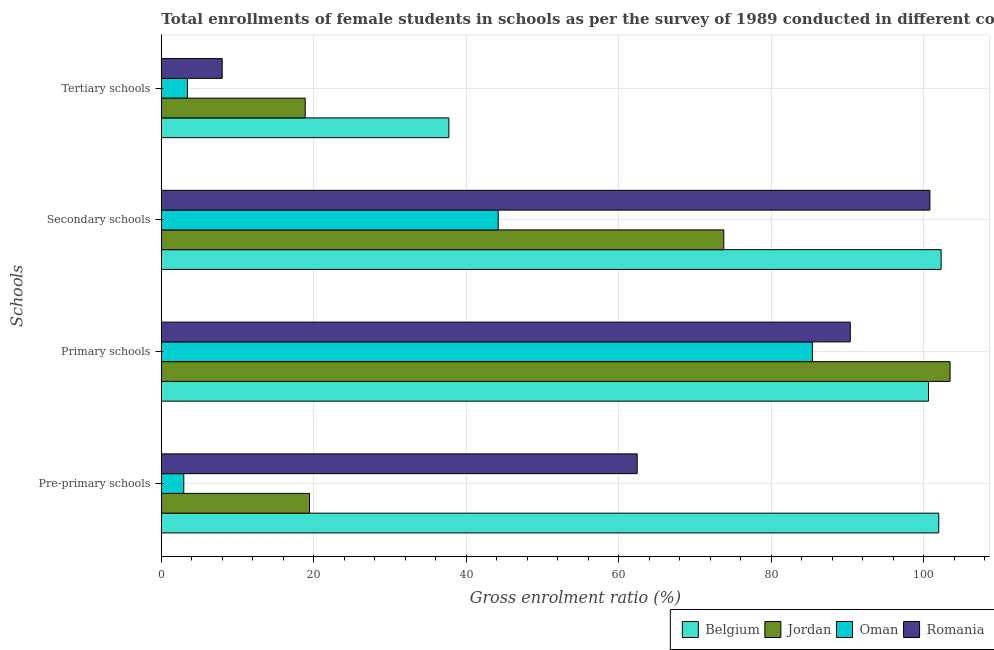How many groups of bars are there?
Make the answer very short. 4. How many bars are there on the 2nd tick from the bottom?
Give a very brief answer. 4. What is the label of the 1st group of bars from the top?
Offer a very short reply. Tertiary schools. What is the gross enrolment ratio(female) in tertiary schools in Jordan?
Offer a terse response. 18.88. Across all countries, what is the maximum gross enrolment ratio(female) in tertiary schools?
Your answer should be very brief. 37.73. Across all countries, what is the minimum gross enrolment ratio(female) in secondary schools?
Ensure brevity in your answer.  44.2. In which country was the gross enrolment ratio(female) in primary schools maximum?
Give a very brief answer. Jordan. In which country was the gross enrolment ratio(female) in secondary schools minimum?
Your answer should be compact. Oman. What is the total gross enrolment ratio(female) in pre-primary schools in the graph?
Your answer should be compact. 186.82. What is the difference between the gross enrolment ratio(female) in primary schools in Romania and that in Belgium?
Offer a very short reply. -10.26. What is the difference between the gross enrolment ratio(female) in tertiary schools in Oman and the gross enrolment ratio(female) in secondary schools in Romania?
Your answer should be very brief. -97.41. What is the average gross enrolment ratio(female) in tertiary schools per country?
Make the answer very short. 17. What is the difference between the gross enrolment ratio(female) in pre-primary schools and gross enrolment ratio(female) in secondary schools in Jordan?
Provide a short and direct response. -54.35. In how many countries, is the gross enrolment ratio(female) in secondary schools greater than 16 %?
Offer a very short reply. 4. What is the ratio of the gross enrolment ratio(female) in tertiary schools in Romania to that in Jordan?
Keep it short and to the point. 0.42. Is the gross enrolment ratio(female) in tertiary schools in Jordan less than that in Belgium?
Keep it short and to the point. Yes. Is the difference between the gross enrolment ratio(female) in primary schools in Belgium and Romania greater than the difference between the gross enrolment ratio(female) in tertiary schools in Belgium and Romania?
Offer a very short reply. No. What is the difference between the highest and the second highest gross enrolment ratio(female) in pre-primary schools?
Offer a very short reply. 39.56. What is the difference between the highest and the lowest gross enrolment ratio(female) in pre-primary schools?
Provide a short and direct response. 99.05. In how many countries, is the gross enrolment ratio(female) in secondary schools greater than the average gross enrolment ratio(female) in secondary schools taken over all countries?
Your response must be concise. 2. Is the sum of the gross enrolment ratio(female) in primary schools in Oman and Romania greater than the maximum gross enrolment ratio(female) in tertiary schools across all countries?
Your response must be concise. Yes. Is it the case that in every country, the sum of the gross enrolment ratio(female) in primary schools and gross enrolment ratio(female) in secondary schools is greater than the sum of gross enrolment ratio(female) in pre-primary schools and gross enrolment ratio(female) in tertiary schools?
Offer a very short reply. Yes. What does the 1st bar from the top in Tertiary schools represents?
Provide a short and direct response. Romania. What does the 3rd bar from the bottom in Primary schools represents?
Your answer should be very brief. Oman. How many bars are there?
Provide a short and direct response. 16. How many countries are there in the graph?
Ensure brevity in your answer.  4. Where does the legend appear in the graph?
Offer a terse response. Bottom right. How many legend labels are there?
Your response must be concise. 4. How are the legend labels stacked?
Make the answer very short. Horizontal. What is the title of the graph?
Offer a terse response. Total enrollments of female students in schools as per the survey of 1989 conducted in different countries. Does "Burundi" appear as one of the legend labels in the graph?
Keep it short and to the point. No. What is the label or title of the X-axis?
Offer a very short reply. Gross enrolment ratio (%). What is the label or title of the Y-axis?
Offer a terse response. Schools. What is the Gross enrolment ratio (%) in Belgium in Pre-primary schools?
Provide a succinct answer. 101.99. What is the Gross enrolment ratio (%) of Jordan in Pre-primary schools?
Offer a terse response. 19.44. What is the Gross enrolment ratio (%) in Oman in Pre-primary schools?
Your answer should be compact. 2.95. What is the Gross enrolment ratio (%) in Romania in Pre-primary schools?
Give a very brief answer. 62.43. What is the Gross enrolment ratio (%) of Belgium in Primary schools?
Offer a very short reply. 100.65. What is the Gross enrolment ratio (%) of Jordan in Primary schools?
Your response must be concise. 103.48. What is the Gross enrolment ratio (%) of Oman in Primary schools?
Provide a short and direct response. 85.43. What is the Gross enrolment ratio (%) in Romania in Primary schools?
Give a very brief answer. 90.39. What is the Gross enrolment ratio (%) of Belgium in Secondary schools?
Give a very brief answer. 102.31. What is the Gross enrolment ratio (%) in Jordan in Secondary schools?
Provide a succinct answer. 73.8. What is the Gross enrolment ratio (%) in Oman in Secondary schools?
Give a very brief answer. 44.2. What is the Gross enrolment ratio (%) in Romania in Secondary schools?
Your response must be concise. 100.83. What is the Gross enrolment ratio (%) of Belgium in Tertiary schools?
Your answer should be very brief. 37.73. What is the Gross enrolment ratio (%) in Jordan in Tertiary schools?
Keep it short and to the point. 18.88. What is the Gross enrolment ratio (%) of Oman in Tertiary schools?
Ensure brevity in your answer.  3.43. What is the Gross enrolment ratio (%) in Romania in Tertiary schools?
Provide a succinct answer. 7.99. Across all Schools, what is the maximum Gross enrolment ratio (%) of Belgium?
Provide a short and direct response. 102.31. Across all Schools, what is the maximum Gross enrolment ratio (%) in Jordan?
Provide a succinct answer. 103.48. Across all Schools, what is the maximum Gross enrolment ratio (%) in Oman?
Provide a short and direct response. 85.43. Across all Schools, what is the maximum Gross enrolment ratio (%) in Romania?
Make the answer very short. 100.83. Across all Schools, what is the minimum Gross enrolment ratio (%) in Belgium?
Ensure brevity in your answer.  37.73. Across all Schools, what is the minimum Gross enrolment ratio (%) in Jordan?
Your response must be concise. 18.88. Across all Schools, what is the minimum Gross enrolment ratio (%) of Oman?
Ensure brevity in your answer.  2.95. Across all Schools, what is the minimum Gross enrolment ratio (%) in Romania?
Provide a short and direct response. 7.99. What is the total Gross enrolment ratio (%) in Belgium in the graph?
Your response must be concise. 342.68. What is the total Gross enrolment ratio (%) in Jordan in the graph?
Provide a short and direct response. 215.59. What is the total Gross enrolment ratio (%) of Oman in the graph?
Provide a succinct answer. 136. What is the total Gross enrolment ratio (%) of Romania in the graph?
Keep it short and to the point. 261.64. What is the difference between the Gross enrolment ratio (%) of Belgium in Pre-primary schools and that in Primary schools?
Your answer should be very brief. 1.35. What is the difference between the Gross enrolment ratio (%) in Jordan in Pre-primary schools and that in Primary schools?
Provide a succinct answer. -84.03. What is the difference between the Gross enrolment ratio (%) in Oman in Pre-primary schools and that in Primary schools?
Ensure brevity in your answer.  -82.48. What is the difference between the Gross enrolment ratio (%) in Romania in Pre-primary schools and that in Primary schools?
Your answer should be compact. -27.96. What is the difference between the Gross enrolment ratio (%) in Belgium in Pre-primary schools and that in Secondary schools?
Your answer should be compact. -0.31. What is the difference between the Gross enrolment ratio (%) of Jordan in Pre-primary schools and that in Secondary schools?
Ensure brevity in your answer.  -54.35. What is the difference between the Gross enrolment ratio (%) in Oman in Pre-primary schools and that in Secondary schools?
Your answer should be compact. -41.25. What is the difference between the Gross enrolment ratio (%) of Romania in Pre-primary schools and that in Secondary schools?
Provide a short and direct response. -38.4. What is the difference between the Gross enrolment ratio (%) of Belgium in Pre-primary schools and that in Tertiary schools?
Offer a terse response. 64.27. What is the difference between the Gross enrolment ratio (%) in Jordan in Pre-primary schools and that in Tertiary schools?
Offer a terse response. 0.57. What is the difference between the Gross enrolment ratio (%) of Oman in Pre-primary schools and that in Tertiary schools?
Your answer should be compact. -0.48. What is the difference between the Gross enrolment ratio (%) of Romania in Pre-primary schools and that in Tertiary schools?
Offer a terse response. 54.45. What is the difference between the Gross enrolment ratio (%) of Belgium in Primary schools and that in Secondary schools?
Keep it short and to the point. -1.66. What is the difference between the Gross enrolment ratio (%) of Jordan in Primary schools and that in Secondary schools?
Offer a terse response. 29.68. What is the difference between the Gross enrolment ratio (%) in Oman in Primary schools and that in Secondary schools?
Provide a succinct answer. 41.23. What is the difference between the Gross enrolment ratio (%) of Romania in Primary schools and that in Secondary schools?
Provide a succinct answer. -10.44. What is the difference between the Gross enrolment ratio (%) of Belgium in Primary schools and that in Tertiary schools?
Keep it short and to the point. 62.92. What is the difference between the Gross enrolment ratio (%) of Jordan in Primary schools and that in Tertiary schools?
Keep it short and to the point. 84.6. What is the difference between the Gross enrolment ratio (%) in Oman in Primary schools and that in Tertiary schools?
Make the answer very short. 82. What is the difference between the Gross enrolment ratio (%) of Romania in Primary schools and that in Tertiary schools?
Provide a succinct answer. 82.4. What is the difference between the Gross enrolment ratio (%) in Belgium in Secondary schools and that in Tertiary schools?
Offer a terse response. 64.58. What is the difference between the Gross enrolment ratio (%) of Jordan in Secondary schools and that in Tertiary schools?
Your response must be concise. 54.92. What is the difference between the Gross enrolment ratio (%) in Oman in Secondary schools and that in Tertiary schools?
Make the answer very short. 40.77. What is the difference between the Gross enrolment ratio (%) in Romania in Secondary schools and that in Tertiary schools?
Provide a short and direct response. 92.85. What is the difference between the Gross enrolment ratio (%) in Belgium in Pre-primary schools and the Gross enrolment ratio (%) in Jordan in Primary schools?
Make the answer very short. -1.48. What is the difference between the Gross enrolment ratio (%) of Belgium in Pre-primary schools and the Gross enrolment ratio (%) of Oman in Primary schools?
Your response must be concise. 16.57. What is the difference between the Gross enrolment ratio (%) of Belgium in Pre-primary schools and the Gross enrolment ratio (%) of Romania in Primary schools?
Your answer should be compact. 11.61. What is the difference between the Gross enrolment ratio (%) in Jordan in Pre-primary schools and the Gross enrolment ratio (%) in Oman in Primary schools?
Offer a very short reply. -65.98. What is the difference between the Gross enrolment ratio (%) in Jordan in Pre-primary schools and the Gross enrolment ratio (%) in Romania in Primary schools?
Offer a very short reply. -70.95. What is the difference between the Gross enrolment ratio (%) in Oman in Pre-primary schools and the Gross enrolment ratio (%) in Romania in Primary schools?
Ensure brevity in your answer.  -87.44. What is the difference between the Gross enrolment ratio (%) of Belgium in Pre-primary schools and the Gross enrolment ratio (%) of Jordan in Secondary schools?
Ensure brevity in your answer.  28.2. What is the difference between the Gross enrolment ratio (%) of Belgium in Pre-primary schools and the Gross enrolment ratio (%) of Oman in Secondary schools?
Your response must be concise. 57.8. What is the difference between the Gross enrolment ratio (%) of Belgium in Pre-primary schools and the Gross enrolment ratio (%) of Romania in Secondary schools?
Your answer should be very brief. 1.16. What is the difference between the Gross enrolment ratio (%) in Jordan in Pre-primary schools and the Gross enrolment ratio (%) in Oman in Secondary schools?
Your answer should be very brief. -24.75. What is the difference between the Gross enrolment ratio (%) in Jordan in Pre-primary schools and the Gross enrolment ratio (%) in Romania in Secondary schools?
Provide a short and direct response. -81.39. What is the difference between the Gross enrolment ratio (%) in Oman in Pre-primary schools and the Gross enrolment ratio (%) in Romania in Secondary schools?
Your response must be concise. -97.88. What is the difference between the Gross enrolment ratio (%) in Belgium in Pre-primary schools and the Gross enrolment ratio (%) in Jordan in Tertiary schools?
Your response must be concise. 83.12. What is the difference between the Gross enrolment ratio (%) of Belgium in Pre-primary schools and the Gross enrolment ratio (%) of Oman in Tertiary schools?
Your answer should be compact. 98.57. What is the difference between the Gross enrolment ratio (%) in Belgium in Pre-primary schools and the Gross enrolment ratio (%) in Romania in Tertiary schools?
Provide a short and direct response. 94.01. What is the difference between the Gross enrolment ratio (%) of Jordan in Pre-primary schools and the Gross enrolment ratio (%) of Oman in Tertiary schools?
Keep it short and to the point. 16.02. What is the difference between the Gross enrolment ratio (%) of Jordan in Pre-primary schools and the Gross enrolment ratio (%) of Romania in Tertiary schools?
Offer a terse response. 11.46. What is the difference between the Gross enrolment ratio (%) in Oman in Pre-primary schools and the Gross enrolment ratio (%) in Romania in Tertiary schools?
Your answer should be compact. -5.04. What is the difference between the Gross enrolment ratio (%) in Belgium in Primary schools and the Gross enrolment ratio (%) in Jordan in Secondary schools?
Ensure brevity in your answer.  26.85. What is the difference between the Gross enrolment ratio (%) of Belgium in Primary schools and the Gross enrolment ratio (%) of Oman in Secondary schools?
Offer a terse response. 56.45. What is the difference between the Gross enrolment ratio (%) in Belgium in Primary schools and the Gross enrolment ratio (%) in Romania in Secondary schools?
Offer a very short reply. -0.19. What is the difference between the Gross enrolment ratio (%) of Jordan in Primary schools and the Gross enrolment ratio (%) of Oman in Secondary schools?
Provide a short and direct response. 59.28. What is the difference between the Gross enrolment ratio (%) in Jordan in Primary schools and the Gross enrolment ratio (%) in Romania in Secondary schools?
Your answer should be compact. 2.65. What is the difference between the Gross enrolment ratio (%) in Oman in Primary schools and the Gross enrolment ratio (%) in Romania in Secondary schools?
Keep it short and to the point. -15.41. What is the difference between the Gross enrolment ratio (%) of Belgium in Primary schools and the Gross enrolment ratio (%) of Jordan in Tertiary schools?
Offer a terse response. 81.77. What is the difference between the Gross enrolment ratio (%) of Belgium in Primary schools and the Gross enrolment ratio (%) of Oman in Tertiary schools?
Your answer should be compact. 97.22. What is the difference between the Gross enrolment ratio (%) in Belgium in Primary schools and the Gross enrolment ratio (%) in Romania in Tertiary schools?
Make the answer very short. 92.66. What is the difference between the Gross enrolment ratio (%) of Jordan in Primary schools and the Gross enrolment ratio (%) of Oman in Tertiary schools?
Ensure brevity in your answer.  100.05. What is the difference between the Gross enrolment ratio (%) of Jordan in Primary schools and the Gross enrolment ratio (%) of Romania in Tertiary schools?
Offer a very short reply. 95.49. What is the difference between the Gross enrolment ratio (%) of Oman in Primary schools and the Gross enrolment ratio (%) of Romania in Tertiary schools?
Your answer should be very brief. 77.44. What is the difference between the Gross enrolment ratio (%) of Belgium in Secondary schools and the Gross enrolment ratio (%) of Jordan in Tertiary schools?
Your answer should be compact. 83.43. What is the difference between the Gross enrolment ratio (%) in Belgium in Secondary schools and the Gross enrolment ratio (%) in Oman in Tertiary schools?
Provide a short and direct response. 98.88. What is the difference between the Gross enrolment ratio (%) in Belgium in Secondary schools and the Gross enrolment ratio (%) in Romania in Tertiary schools?
Your answer should be compact. 94.32. What is the difference between the Gross enrolment ratio (%) of Jordan in Secondary schools and the Gross enrolment ratio (%) of Oman in Tertiary schools?
Provide a short and direct response. 70.37. What is the difference between the Gross enrolment ratio (%) of Jordan in Secondary schools and the Gross enrolment ratio (%) of Romania in Tertiary schools?
Give a very brief answer. 65.81. What is the difference between the Gross enrolment ratio (%) of Oman in Secondary schools and the Gross enrolment ratio (%) of Romania in Tertiary schools?
Provide a succinct answer. 36.21. What is the average Gross enrolment ratio (%) of Belgium per Schools?
Ensure brevity in your answer.  85.67. What is the average Gross enrolment ratio (%) in Jordan per Schools?
Make the answer very short. 53.9. What is the average Gross enrolment ratio (%) in Oman per Schools?
Give a very brief answer. 34. What is the average Gross enrolment ratio (%) in Romania per Schools?
Your response must be concise. 65.41. What is the difference between the Gross enrolment ratio (%) of Belgium and Gross enrolment ratio (%) of Jordan in Pre-primary schools?
Your answer should be very brief. 82.55. What is the difference between the Gross enrolment ratio (%) of Belgium and Gross enrolment ratio (%) of Oman in Pre-primary schools?
Provide a succinct answer. 99.05. What is the difference between the Gross enrolment ratio (%) in Belgium and Gross enrolment ratio (%) in Romania in Pre-primary schools?
Your response must be concise. 39.56. What is the difference between the Gross enrolment ratio (%) of Jordan and Gross enrolment ratio (%) of Oman in Pre-primary schools?
Your answer should be very brief. 16.5. What is the difference between the Gross enrolment ratio (%) in Jordan and Gross enrolment ratio (%) in Romania in Pre-primary schools?
Provide a short and direct response. -42.99. What is the difference between the Gross enrolment ratio (%) of Oman and Gross enrolment ratio (%) of Romania in Pre-primary schools?
Your response must be concise. -59.49. What is the difference between the Gross enrolment ratio (%) in Belgium and Gross enrolment ratio (%) in Jordan in Primary schools?
Make the answer very short. -2.83. What is the difference between the Gross enrolment ratio (%) in Belgium and Gross enrolment ratio (%) in Oman in Primary schools?
Offer a terse response. 15.22. What is the difference between the Gross enrolment ratio (%) in Belgium and Gross enrolment ratio (%) in Romania in Primary schools?
Keep it short and to the point. 10.26. What is the difference between the Gross enrolment ratio (%) in Jordan and Gross enrolment ratio (%) in Oman in Primary schools?
Your answer should be very brief. 18.05. What is the difference between the Gross enrolment ratio (%) in Jordan and Gross enrolment ratio (%) in Romania in Primary schools?
Your response must be concise. 13.09. What is the difference between the Gross enrolment ratio (%) of Oman and Gross enrolment ratio (%) of Romania in Primary schools?
Provide a succinct answer. -4.96. What is the difference between the Gross enrolment ratio (%) in Belgium and Gross enrolment ratio (%) in Jordan in Secondary schools?
Provide a succinct answer. 28.51. What is the difference between the Gross enrolment ratio (%) in Belgium and Gross enrolment ratio (%) in Oman in Secondary schools?
Provide a succinct answer. 58.11. What is the difference between the Gross enrolment ratio (%) of Belgium and Gross enrolment ratio (%) of Romania in Secondary schools?
Give a very brief answer. 1.47. What is the difference between the Gross enrolment ratio (%) in Jordan and Gross enrolment ratio (%) in Oman in Secondary schools?
Provide a succinct answer. 29.6. What is the difference between the Gross enrolment ratio (%) in Jordan and Gross enrolment ratio (%) in Romania in Secondary schools?
Provide a succinct answer. -27.04. What is the difference between the Gross enrolment ratio (%) in Oman and Gross enrolment ratio (%) in Romania in Secondary schools?
Ensure brevity in your answer.  -56.64. What is the difference between the Gross enrolment ratio (%) of Belgium and Gross enrolment ratio (%) of Jordan in Tertiary schools?
Make the answer very short. 18.85. What is the difference between the Gross enrolment ratio (%) of Belgium and Gross enrolment ratio (%) of Oman in Tertiary schools?
Your answer should be compact. 34.3. What is the difference between the Gross enrolment ratio (%) of Belgium and Gross enrolment ratio (%) of Romania in Tertiary schools?
Offer a terse response. 29.74. What is the difference between the Gross enrolment ratio (%) of Jordan and Gross enrolment ratio (%) of Oman in Tertiary schools?
Your response must be concise. 15.45. What is the difference between the Gross enrolment ratio (%) in Jordan and Gross enrolment ratio (%) in Romania in Tertiary schools?
Ensure brevity in your answer.  10.89. What is the difference between the Gross enrolment ratio (%) of Oman and Gross enrolment ratio (%) of Romania in Tertiary schools?
Give a very brief answer. -4.56. What is the ratio of the Gross enrolment ratio (%) of Belgium in Pre-primary schools to that in Primary schools?
Your answer should be very brief. 1.01. What is the ratio of the Gross enrolment ratio (%) in Jordan in Pre-primary schools to that in Primary schools?
Ensure brevity in your answer.  0.19. What is the ratio of the Gross enrolment ratio (%) in Oman in Pre-primary schools to that in Primary schools?
Offer a very short reply. 0.03. What is the ratio of the Gross enrolment ratio (%) of Romania in Pre-primary schools to that in Primary schools?
Your answer should be very brief. 0.69. What is the ratio of the Gross enrolment ratio (%) in Jordan in Pre-primary schools to that in Secondary schools?
Make the answer very short. 0.26. What is the ratio of the Gross enrolment ratio (%) of Oman in Pre-primary schools to that in Secondary schools?
Ensure brevity in your answer.  0.07. What is the ratio of the Gross enrolment ratio (%) of Romania in Pre-primary schools to that in Secondary schools?
Ensure brevity in your answer.  0.62. What is the ratio of the Gross enrolment ratio (%) in Belgium in Pre-primary schools to that in Tertiary schools?
Keep it short and to the point. 2.7. What is the ratio of the Gross enrolment ratio (%) in Jordan in Pre-primary schools to that in Tertiary schools?
Ensure brevity in your answer.  1.03. What is the ratio of the Gross enrolment ratio (%) in Oman in Pre-primary schools to that in Tertiary schools?
Your response must be concise. 0.86. What is the ratio of the Gross enrolment ratio (%) in Romania in Pre-primary schools to that in Tertiary schools?
Offer a very short reply. 7.82. What is the ratio of the Gross enrolment ratio (%) of Belgium in Primary schools to that in Secondary schools?
Your response must be concise. 0.98. What is the ratio of the Gross enrolment ratio (%) of Jordan in Primary schools to that in Secondary schools?
Your answer should be very brief. 1.4. What is the ratio of the Gross enrolment ratio (%) in Oman in Primary schools to that in Secondary schools?
Ensure brevity in your answer.  1.93. What is the ratio of the Gross enrolment ratio (%) of Romania in Primary schools to that in Secondary schools?
Give a very brief answer. 0.9. What is the ratio of the Gross enrolment ratio (%) of Belgium in Primary schools to that in Tertiary schools?
Your response must be concise. 2.67. What is the ratio of the Gross enrolment ratio (%) in Jordan in Primary schools to that in Tertiary schools?
Offer a terse response. 5.48. What is the ratio of the Gross enrolment ratio (%) of Oman in Primary schools to that in Tertiary schools?
Your answer should be very brief. 24.92. What is the ratio of the Gross enrolment ratio (%) in Romania in Primary schools to that in Tertiary schools?
Your answer should be compact. 11.32. What is the ratio of the Gross enrolment ratio (%) of Belgium in Secondary schools to that in Tertiary schools?
Keep it short and to the point. 2.71. What is the ratio of the Gross enrolment ratio (%) in Jordan in Secondary schools to that in Tertiary schools?
Provide a short and direct response. 3.91. What is the ratio of the Gross enrolment ratio (%) of Oman in Secondary schools to that in Tertiary schools?
Offer a terse response. 12.89. What is the ratio of the Gross enrolment ratio (%) in Romania in Secondary schools to that in Tertiary schools?
Make the answer very short. 12.63. What is the difference between the highest and the second highest Gross enrolment ratio (%) of Belgium?
Offer a terse response. 0.31. What is the difference between the highest and the second highest Gross enrolment ratio (%) of Jordan?
Give a very brief answer. 29.68. What is the difference between the highest and the second highest Gross enrolment ratio (%) in Oman?
Keep it short and to the point. 41.23. What is the difference between the highest and the second highest Gross enrolment ratio (%) of Romania?
Provide a short and direct response. 10.44. What is the difference between the highest and the lowest Gross enrolment ratio (%) in Belgium?
Offer a very short reply. 64.58. What is the difference between the highest and the lowest Gross enrolment ratio (%) in Jordan?
Provide a short and direct response. 84.6. What is the difference between the highest and the lowest Gross enrolment ratio (%) of Oman?
Your response must be concise. 82.48. What is the difference between the highest and the lowest Gross enrolment ratio (%) in Romania?
Provide a succinct answer. 92.85. 